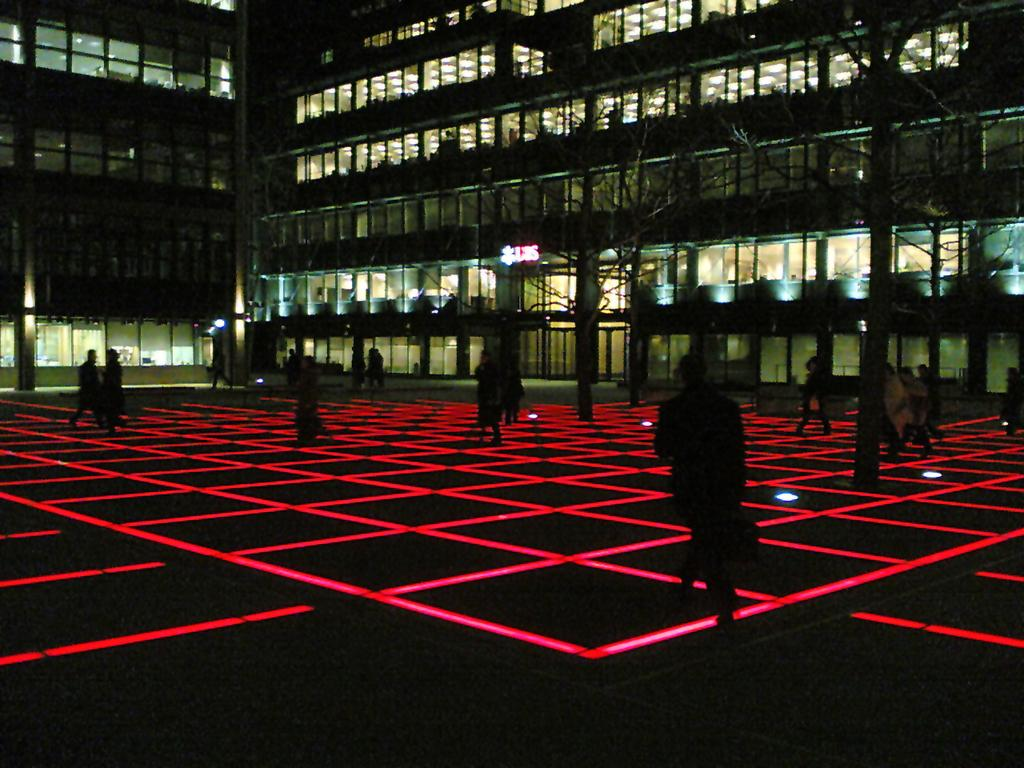Who or what is present in the image? There are people in the image. What can be seen illuminating the scene? There are lights in the image. What is on the ground that is visible in the image? There are radium stickers on the ground. What type of natural elements can be seen in the background of the image? There are trees visible in the background of the image. What type of structures can be seen in the background of the image? There are buildings with glass windows in the background of the image. What type of glue is being used to hold the substance in the image? There is no substance or glue present in the image; it features people, lights, radium stickers, trees, and buildings. 